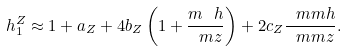Convert formula to latex. <formula><loc_0><loc_0><loc_500><loc_500>h ^ { Z } _ { 1 } \approx 1 + a _ { Z } + 4 b _ { Z } \left ( 1 + \frac { m _ { \ } h } { \ m z } \right ) + 2 c _ { Z } \frac { \ m m h } { \ m m z } . \\</formula> 